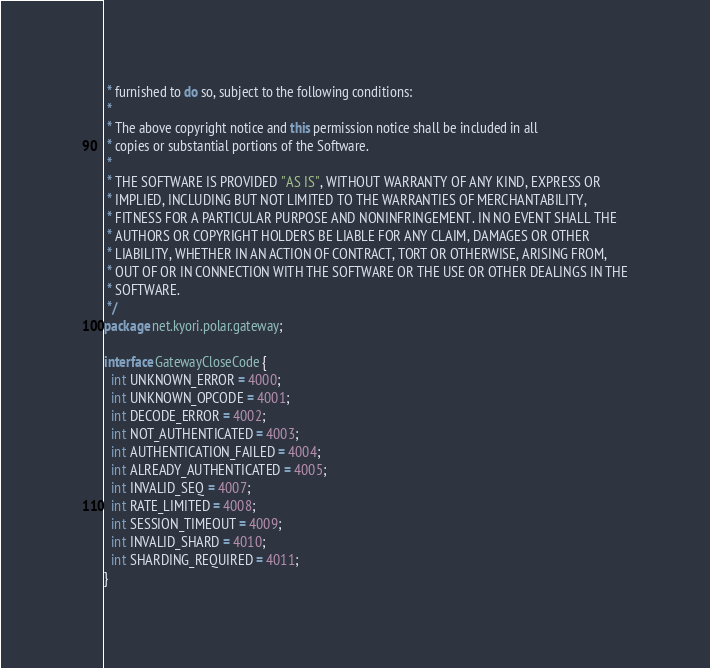<code> <loc_0><loc_0><loc_500><loc_500><_Java_> * furnished to do so, subject to the following conditions:
 *
 * The above copyright notice and this permission notice shall be included in all
 * copies or substantial portions of the Software.
 *
 * THE SOFTWARE IS PROVIDED "AS IS", WITHOUT WARRANTY OF ANY KIND, EXPRESS OR
 * IMPLIED, INCLUDING BUT NOT LIMITED TO THE WARRANTIES OF MERCHANTABILITY,
 * FITNESS FOR A PARTICULAR PURPOSE AND NONINFRINGEMENT. IN NO EVENT SHALL THE
 * AUTHORS OR COPYRIGHT HOLDERS BE LIABLE FOR ANY CLAIM, DAMAGES OR OTHER
 * LIABILITY, WHETHER IN AN ACTION OF CONTRACT, TORT OR OTHERWISE, ARISING FROM,
 * OUT OF OR IN CONNECTION WITH THE SOFTWARE OR THE USE OR OTHER DEALINGS IN THE
 * SOFTWARE.
 */
package net.kyori.polar.gateway;

interface GatewayCloseCode {
  int UNKNOWN_ERROR = 4000;
  int UNKNOWN_OPCODE = 4001;
  int DECODE_ERROR = 4002;
  int NOT_AUTHENTICATED = 4003;
  int AUTHENTICATION_FAILED = 4004;
  int ALREADY_AUTHENTICATED = 4005;
  int INVALID_SEQ = 4007;
  int RATE_LIMITED = 4008;
  int SESSION_TIMEOUT = 4009;
  int INVALID_SHARD = 4010;
  int SHARDING_REQUIRED = 4011;
}
</code> 